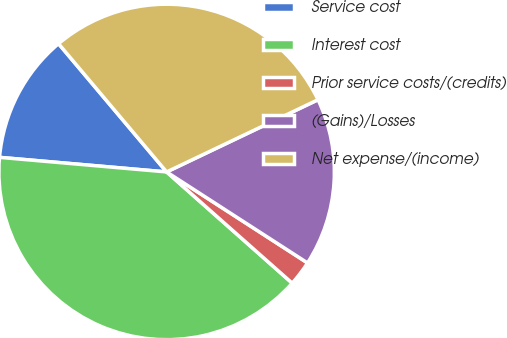Convert chart to OTSL. <chart><loc_0><loc_0><loc_500><loc_500><pie_chart><fcel>Service cost<fcel>Interest cost<fcel>Prior service costs/(credits)<fcel>(Gains)/Losses<fcel>Net expense/(income)<nl><fcel>12.47%<fcel>39.85%<fcel>2.41%<fcel>16.21%<fcel>29.06%<nl></chart> 